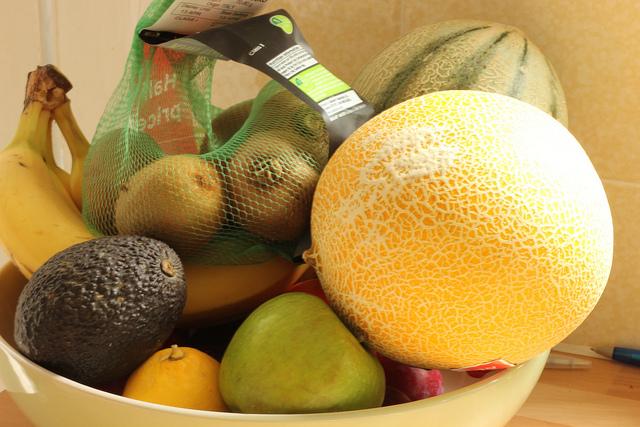Are all the items in the bowl fruits?
Concise answer only. Yes. What is the light green item?
Be succinct. Apple. What is the biggest fruit here?
Keep it brief. Cantaloupe. 